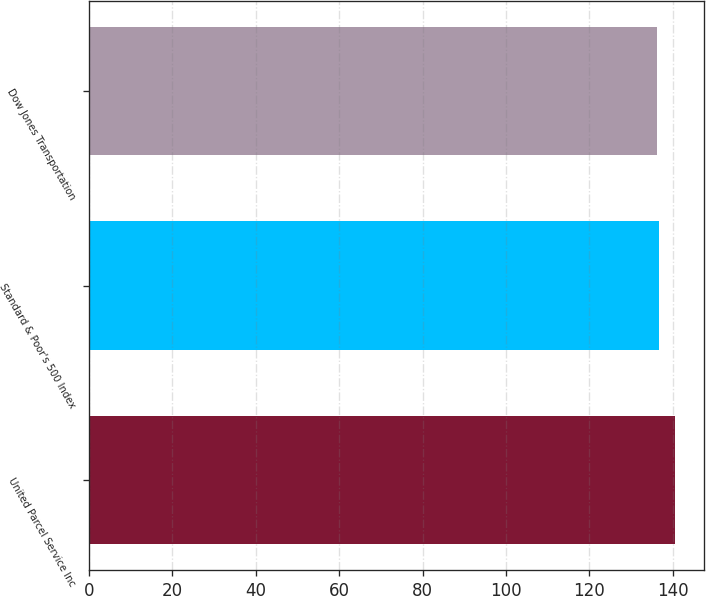<chart> <loc_0><loc_0><loc_500><loc_500><bar_chart><fcel>United Parcel Service Inc<fcel>Standard & Poor's 500 Index<fcel>Dow Jones Transportation<nl><fcel>140.54<fcel>136.67<fcel>136.24<nl></chart> 